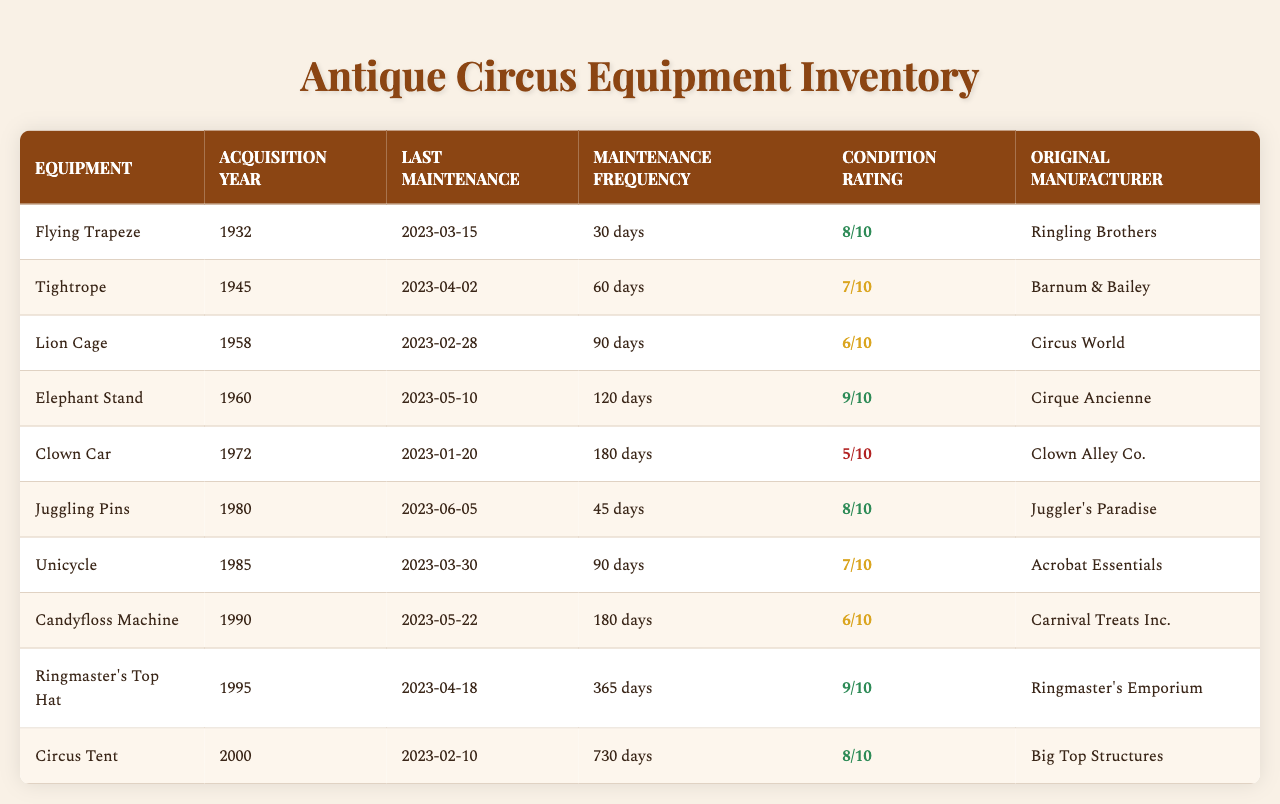What is the condition rating of the Clown Car? Looking at the table, the condition rating for the Clown Car is listed in the fifth column. It shows a rating of 5 out of 10.
Answer: 5 When was the last maintenance performed on the Flying Trapeze? Referring to the last maintenance column for the Flying Trapeze, it indicates that the last maintenance was completed on March 15, 2023.
Answer: March 15, 2023 How many days is the maintenance frequency for the Elephant Stand? The maintenance frequency for the Elephant Stand is found in the fourth column. It states that the maintenance is to be done every 120 days.
Answer: 120 days Which equipment has the highest condition rating? By examining the condition ratings in the table, the Flying Trapeze and the Elephant Stand both have the highest rating of 9 out of 10.
Answer: Flying Trapeze and Elephant Stand What is the average condition rating of all equipment? To find the average, add all condition ratings: (8 + 7 + 6 + 9 + 5 + 8 + 7 + 6 + 9 + 8) = 79. There are 10 equipment items, so the average is 79/10 = 7.9.
Answer: 7.9 Who was the original manufacturer of the Unicycle? The original manufacturer for the Unicycle can be found in the sixth column of the table, which states that it was manufactured by Acrobat Essentials.
Answer: Acrobat Essentials Is the Lion Cage maintained more frequently than the Candyfloss Machine? The Lion Cage has a maintenance frequency of 90 days, while the Candyfloss Machine has a frequency of 180 days. Therefore, the Lion Cage is maintained more frequently.
Answer: Yes How many pieces of equipment were acquired before 1950? Equipment acquired before 1950 includes the Flying Trapeze (1932) and the Tightrope (1945). That totals to 2 pieces of equipment.
Answer: 2 What is the difference in maintenance frequency days between the Tightrope and the Clown Car? The Tightrope has a maintenance frequency of 60 days, and the Clown Car has 180 days. Thus, the difference is 180 - 60 = 120 days.
Answer: 120 days Which equipment was acquired most recently and what is its condition rating? The most recently acquired equipment is the Circus Tent, acquired in 2000. Its condition rating is 8 out of 10.
Answer: Circus Tent, 8/10 